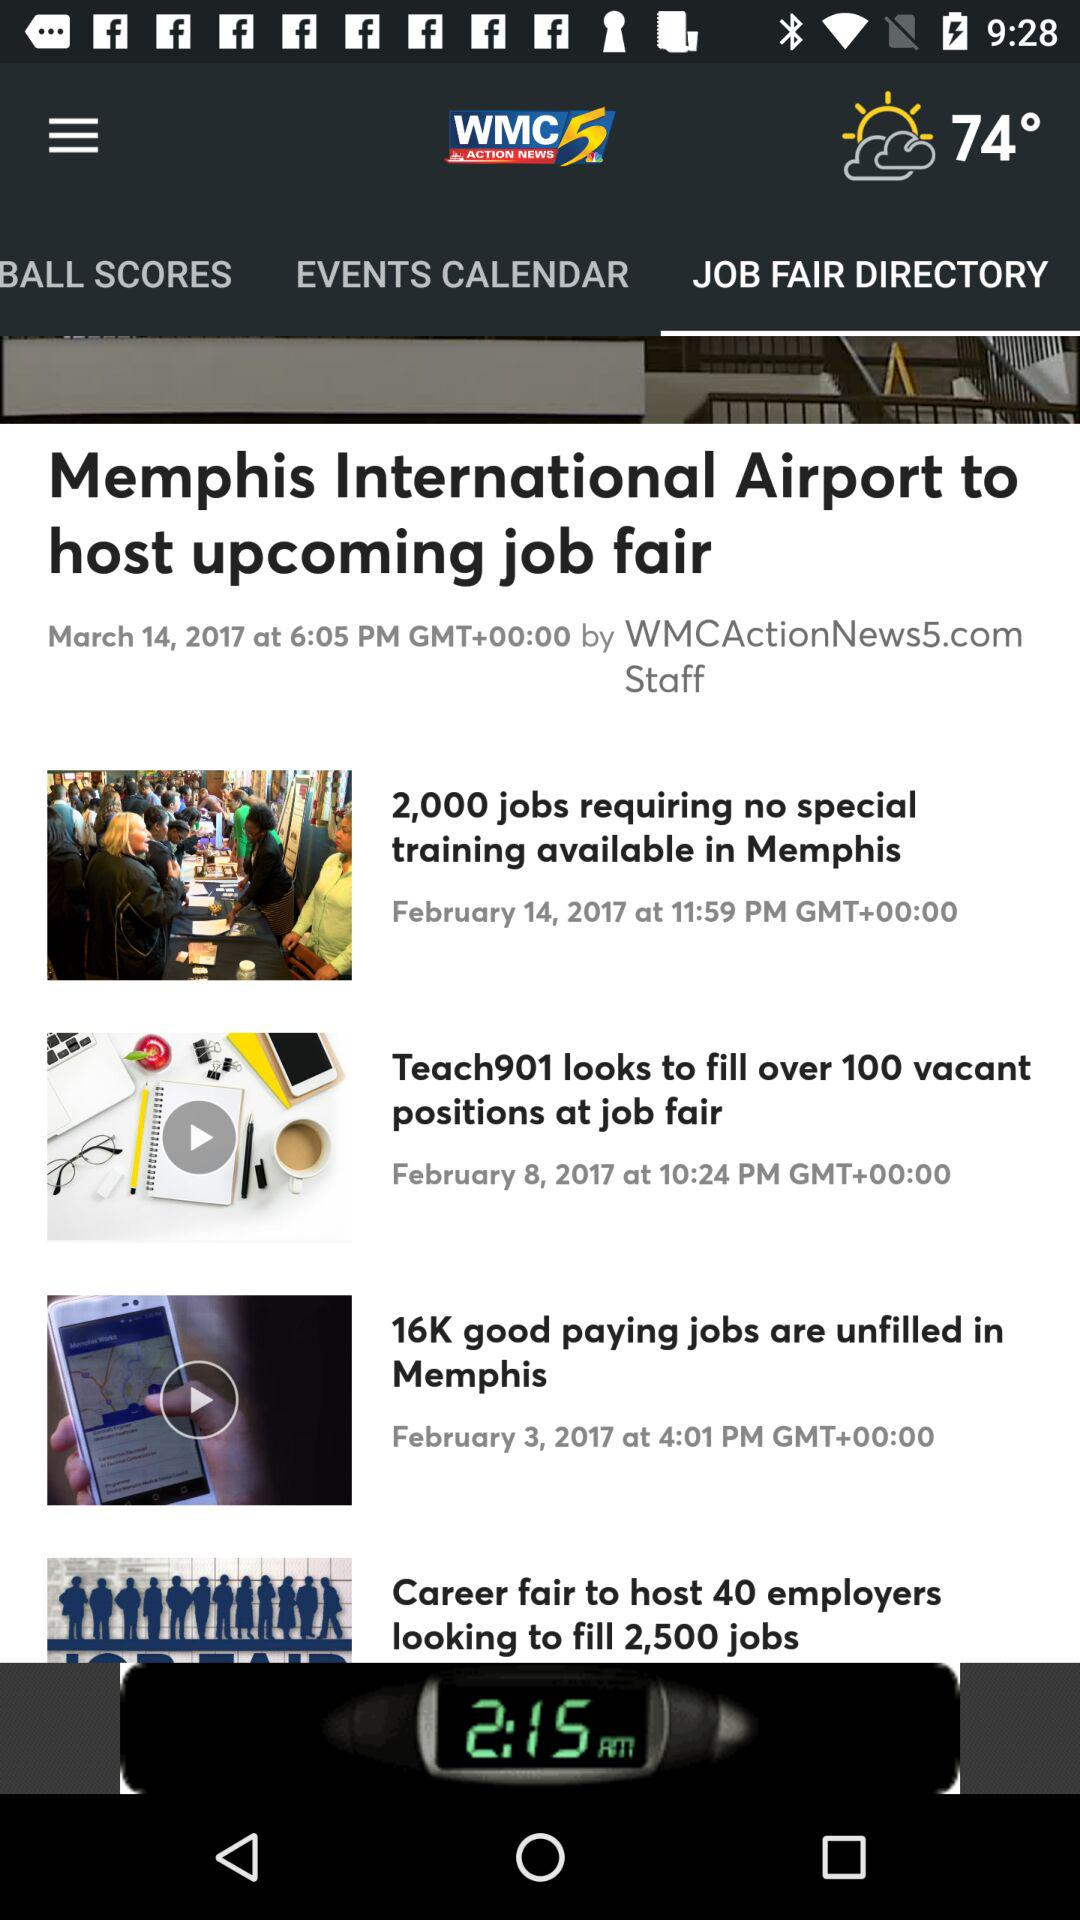What is the date of the article "16K good paying jobs are unfilled in Memphis"? The date of the article "16K good paying jobs are unfilled in Memphis" is 3rd February, 2017. 